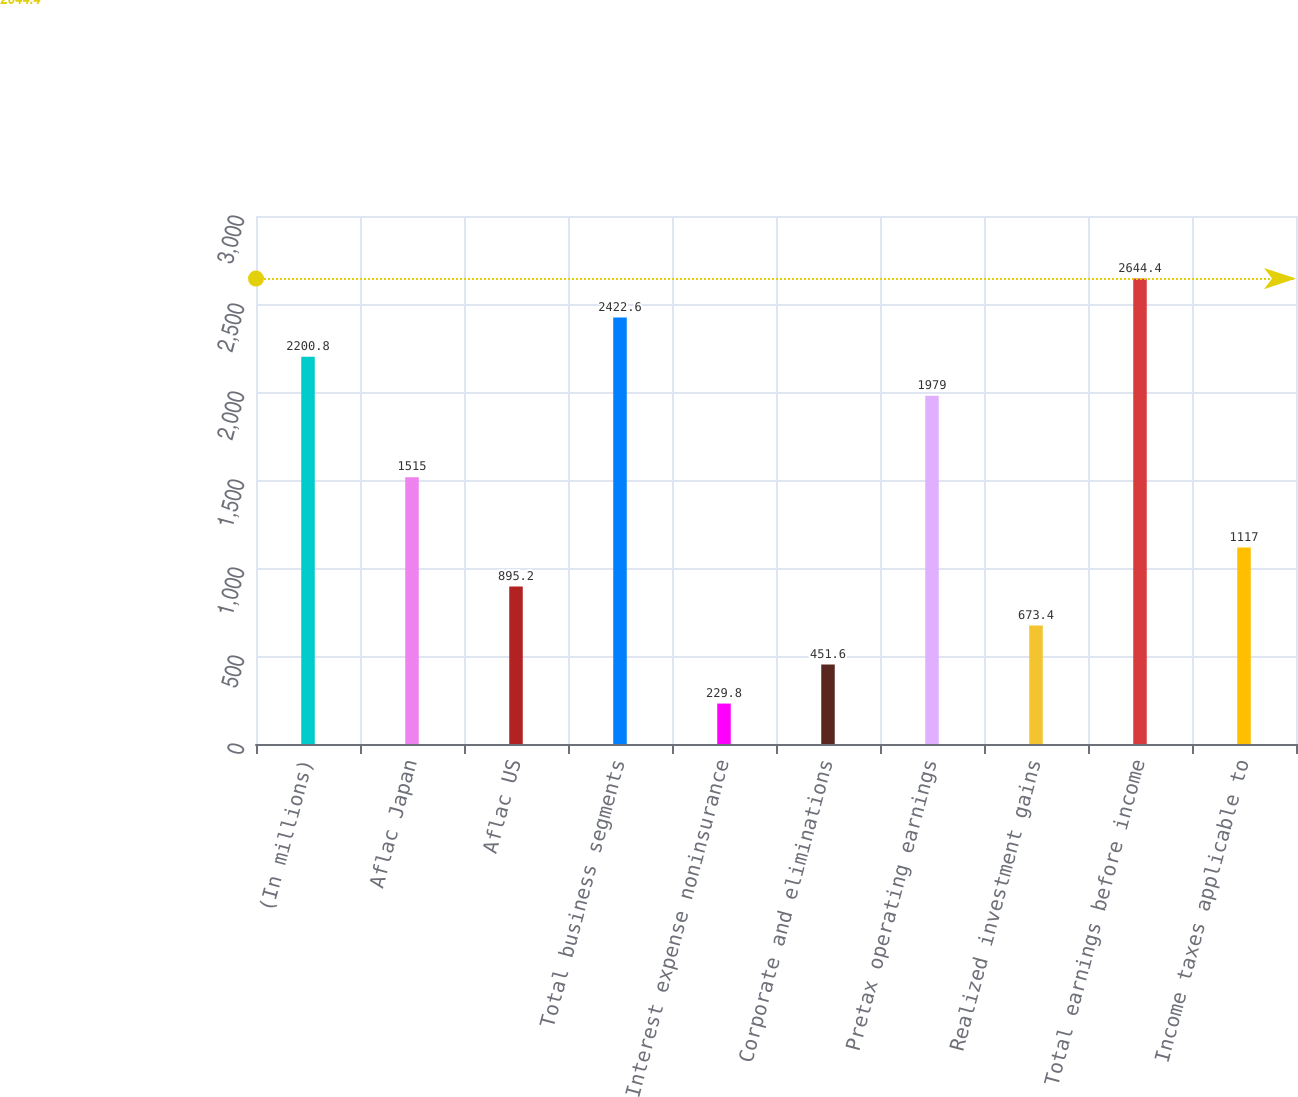<chart> <loc_0><loc_0><loc_500><loc_500><bar_chart><fcel>(In millions)<fcel>Aflac Japan<fcel>Aflac US<fcel>Total business segments<fcel>Interest expense noninsurance<fcel>Corporate and eliminations<fcel>Pretax operating earnings<fcel>Realized investment gains<fcel>Total earnings before income<fcel>Income taxes applicable to<nl><fcel>2200.8<fcel>1515<fcel>895.2<fcel>2422.6<fcel>229.8<fcel>451.6<fcel>1979<fcel>673.4<fcel>2644.4<fcel>1117<nl></chart> 